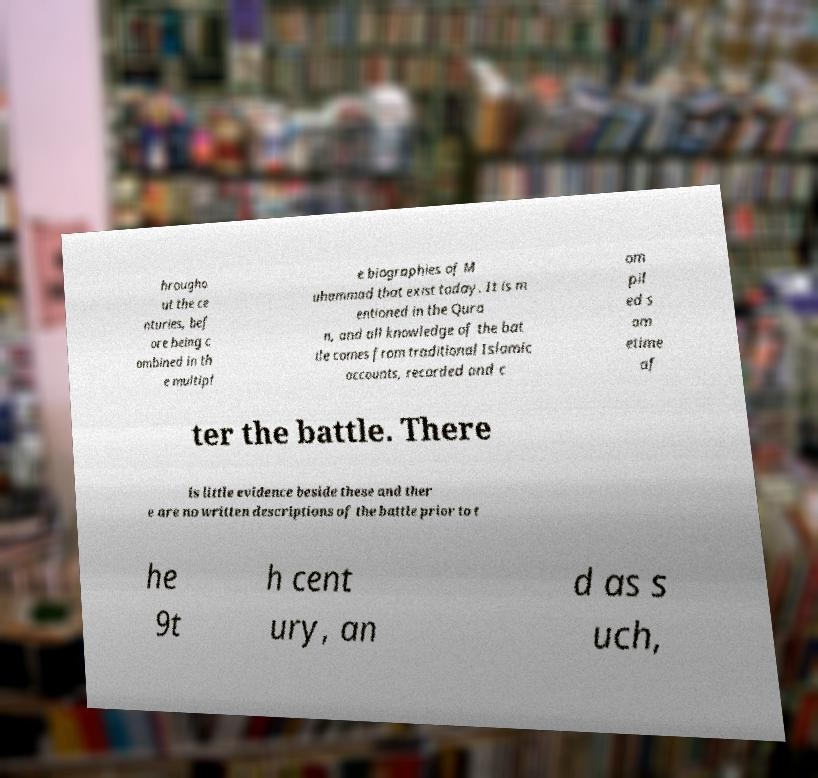There's text embedded in this image that I need extracted. Can you transcribe it verbatim? hrougho ut the ce nturies, bef ore being c ombined in th e multipl e biographies of M uhammad that exist today. It is m entioned in the Qura n, and all knowledge of the bat tle comes from traditional Islamic accounts, recorded and c om pil ed s om etime af ter the battle. There is little evidence beside these and ther e are no written descriptions of the battle prior to t he 9t h cent ury, an d as s uch, 